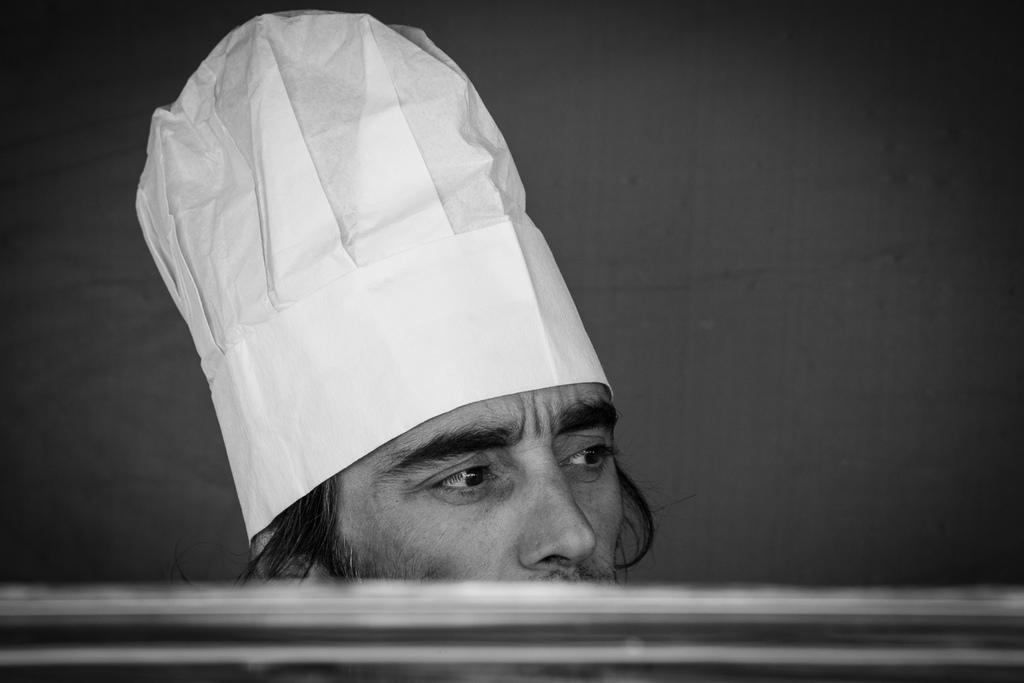What is the color scheme of the image? The image is black and white. Can you describe the person in the image? There is a person in the image. What type of clothing or accessory is the person wearing? The person is wearing a white color chef cap. What type of chin is visible on the person in the image? There is no chin visible on the person in the image, as the image is black and white and does not show any facial features. Can you tell me how many snails are crawling on the person's mind in the image? There are no snails or any reference to a person's mind present in the image. 